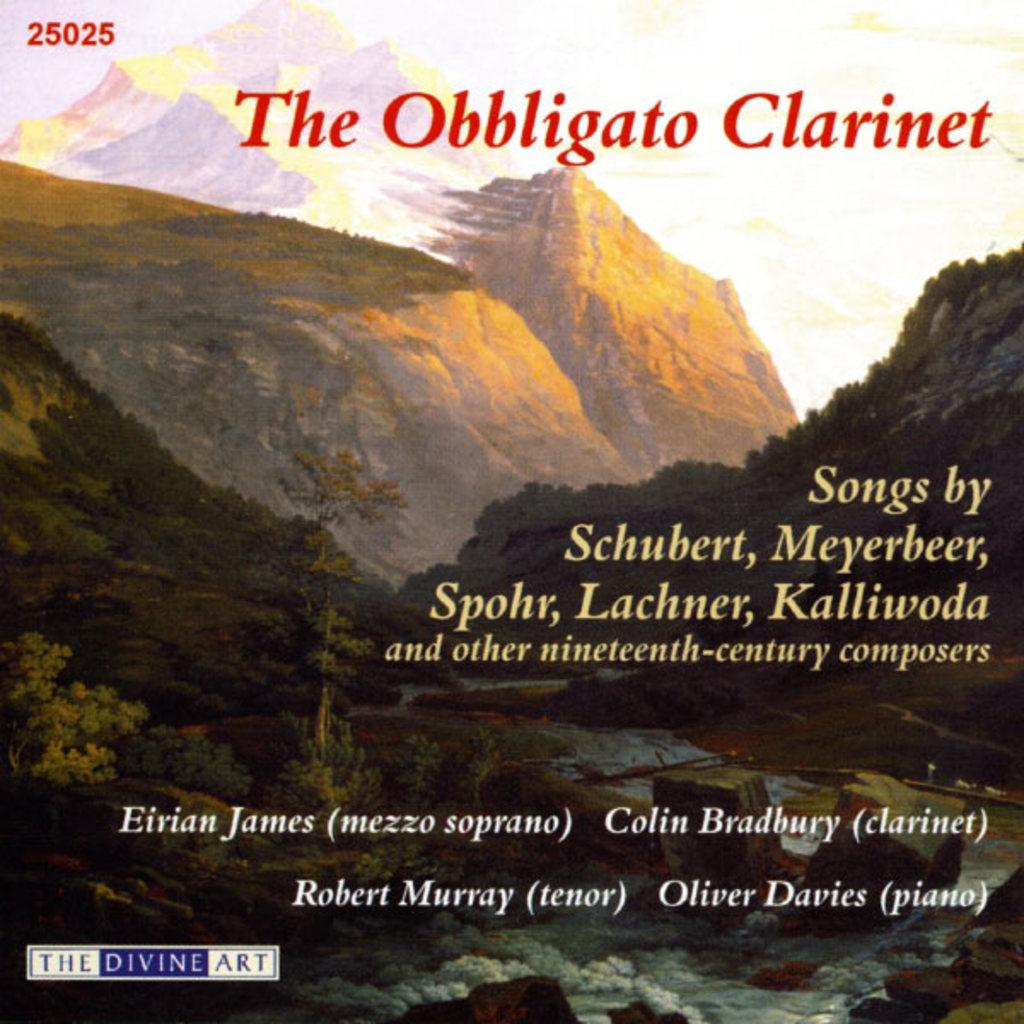What is shown on the poster in the image? The poster in the image depicts mountains, trees, and the sky. Are there any text elements on the poster? Yes, there are words, numbers, and symbols on the poster. What type of coil can be seen in the image? There is no coil present in the image; it features a poster with mountains, trees, and the sky, along with text elements. What reward is being offered for finding trouble in the image? There is no reward or mention of trouble in the image; it only contains a poster with the mentioned elements. 